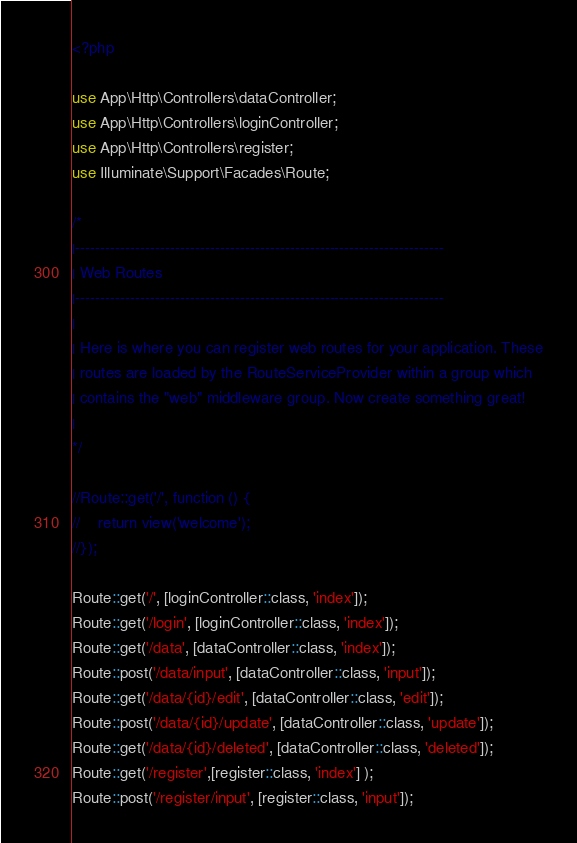Convert code to text. <code><loc_0><loc_0><loc_500><loc_500><_PHP_><?php

use App\Http\Controllers\dataController;
use App\Http\Controllers\loginController;
use App\Http\Controllers\register;
use Illuminate\Support\Facades\Route;

/*
|--------------------------------------------------------------------------
| Web Routes
|--------------------------------------------------------------------------
|
| Here is where you can register web routes for your application. These
| routes are loaded by the RouteServiceProvider within a group which
| contains the "web" middleware group. Now create something great!
|
*/

//Route::get('/', function () {
//    return view('welcome');
//});

Route::get('/', [loginController::class, 'index']);
Route::get('/login', [loginController::class, 'index']);
Route::get('/data', [dataController::class, 'index']); 
Route::post('/data/input', [dataController::class, 'input']);
Route::get('/data/{id}/edit', [dataController::class, 'edit']);
Route::post('/data/{id}/update', [dataController::class, 'update']);
Route::get('/data/{id}/deleted', [dataController::class, 'deleted']);
Route::get('/register',[register::class, 'index'] );
Route::post('/register/input', [register::class, 'input']);</code> 